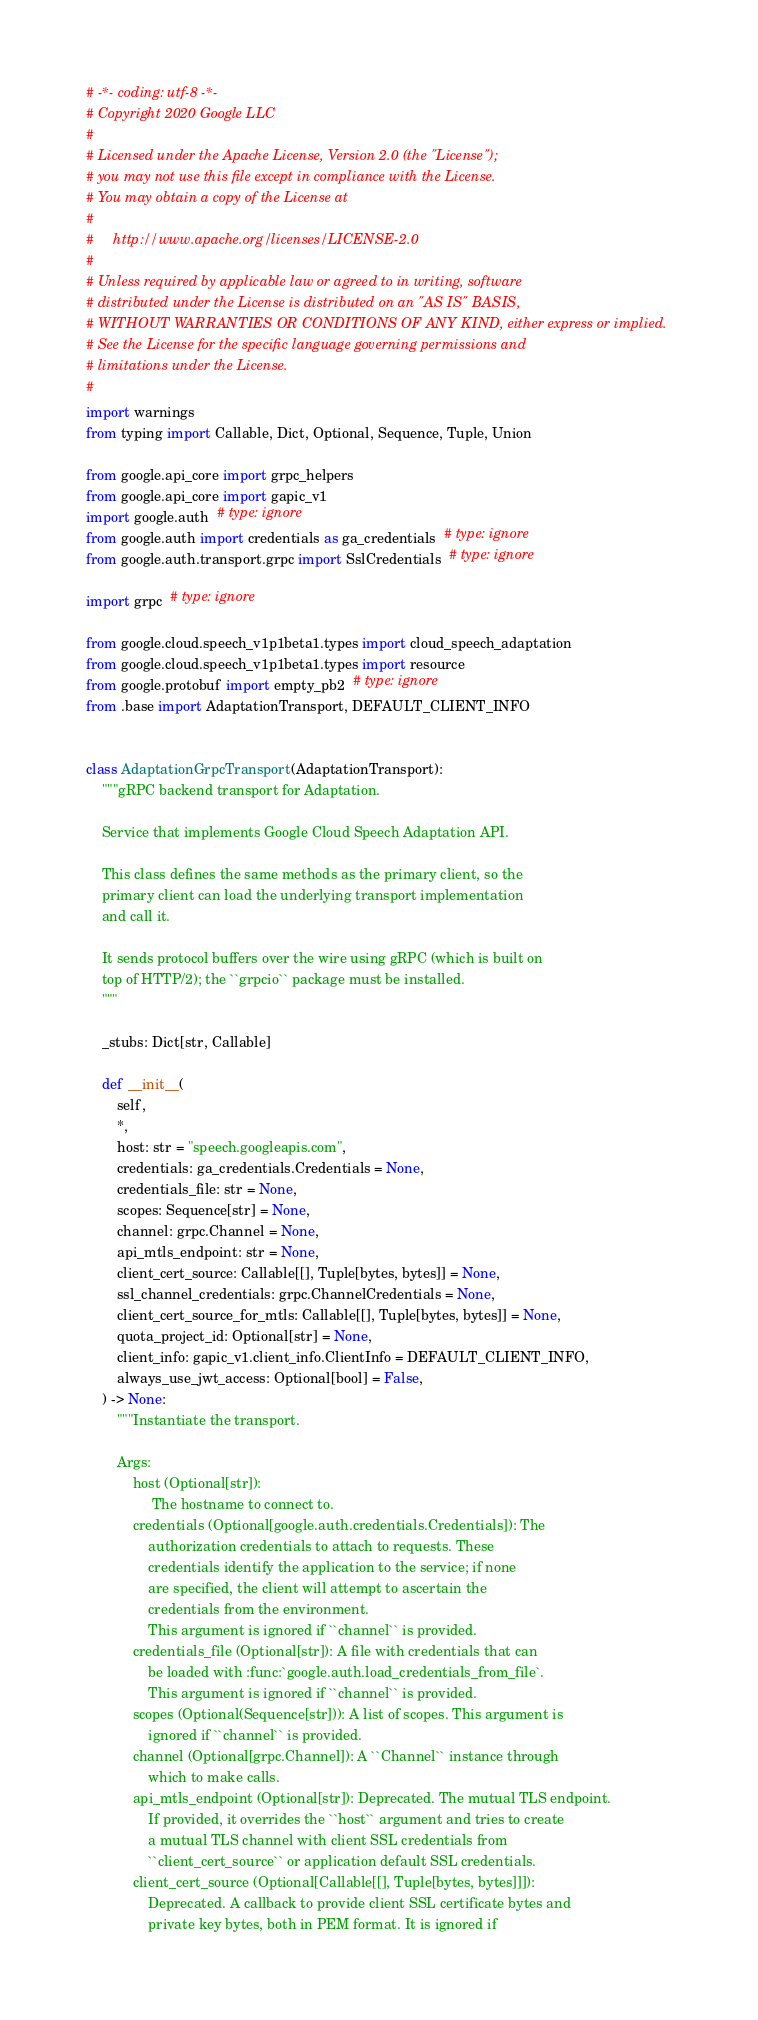<code> <loc_0><loc_0><loc_500><loc_500><_Python_># -*- coding: utf-8 -*-
# Copyright 2020 Google LLC
#
# Licensed under the Apache License, Version 2.0 (the "License");
# you may not use this file except in compliance with the License.
# You may obtain a copy of the License at
#
#     http://www.apache.org/licenses/LICENSE-2.0
#
# Unless required by applicable law or agreed to in writing, software
# distributed under the License is distributed on an "AS IS" BASIS,
# WITHOUT WARRANTIES OR CONDITIONS OF ANY KIND, either express or implied.
# See the License for the specific language governing permissions and
# limitations under the License.
#
import warnings
from typing import Callable, Dict, Optional, Sequence, Tuple, Union

from google.api_core import grpc_helpers
from google.api_core import gapic_v1
import google.auth  # type: ignore
from google.auth import credentials as ga_credentials  # type: ignore
from google.auth.transport.grpc import SslCredentials  # type: ignore

import grpc  # type: ignore

from google.cloud.speech_v1p1beta1.types import cloud_speech_adaptation
from google.cloud.speech_v1p1beta1.types import resource
from google.protobuf import empty_pb2  # type: ignore
from .base import AdaptationTransport, DEFAULT_CLIENT_INFO


class AdaptationGrpcTransport(AdaptationTransport):
    """gRPC backend transport for Adaptation.

    Service that implements Google Cloud Speech Adaptation API.

    This class defines the same methods as the primary client, so the
    primary client can load the underlying transport implementation
    and call it.

    It sends protocol buffers over the wire using gRPC (which is built on
    top of HTTP/2); the ``grpcio`` package must be installed.
    """

    _stubs: Dict[str, Callable]

    def __init__(
        self,
        *,
        host: str = "speech.googleapis.com",
        credentials: ga_credentials.Credentials = None,
        credentials_file: str = None,
        scopes: Sequence[str] = None,
        channel: grpc.Channel = None,
        api_mtls_endpoint: str = None,
        client_cert_source: Callable[[], Tuple[bytes, bytes]] = None,
        ssl_channel_credentials: grpc.ChannelCredentials = None,
        client_cert_source_for_mtls: Callable[[], Tuple[bytes, bytes]] = None,
        quota_project_id: Optional[str] = None,
        client_info: gapic_v1.client_info.ClientInfo = DEFAULT_CLIENT_INFO,
        always_use_jwt_access: Optional[bool] = False,
    ) -> None:
        """Instantiate the transport.

        Args:
            host (Optional[str]):
                 The hostname to connect to.
            credentials (Optional[google.auth.credentials.Credentials]): The
                authorization credentials to attach to requests. These
                credentials identify the application to the service; if none
                are specified, the client will attempt to ascertain the
                credentials from the environment.
                This argument is ignored if ``channel`` is provided.
            credentials_file (Optional[str]): A file with credentials that can
                be loaded with :func:`google.auth.load_credentials_from_file`.
                This argument is ignored if ``channel`` is provided.
            scopes (Optional(Sequence[str])): A list of scopes. This argument is
                ignored if ``channel`` is provided.
            channel (Optional[grpc.Channel]): A ``Channel`` instance through
                which to make calls.
            api_mtls_endpoint (Optional[str]): Deprecated. The mutual TLS endpoint.
                If provided, it overrides the ``host`` argument and tries to create
                a mutual TLS channel with client SSL credentials from
                ``client_cert_source`` or application default SSL credentials.
            client_cert_source (Optional[Callable[[], Tuple[bytes, bytes]]]):
                Deprecated. A callback to provide client SSL certificate bytes and
                private key bytes, both in PEM format. It is ignored if</code> 